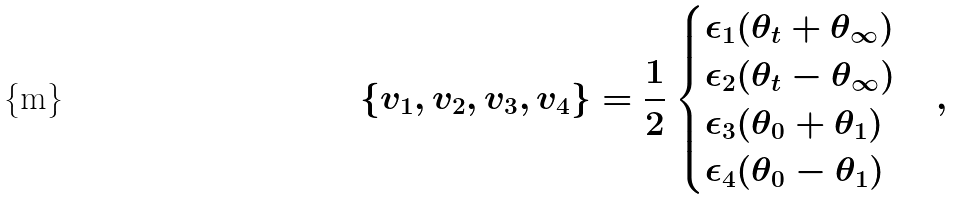Convert formula to latex. <formula><loc_0><loc_0><loc_500><loc_500>\{ v _ { 1 } , v _ { 2 } , v _ { 3 } , v _ { 4 } \} = \frac { 1 } { 2 } \begin{cases} \epsilon _ { 1 } ( \theta _ { t } + \theta _ { \infty } ) \\ \epsilon _ { 2 } ( \theta _ { t } - \theta _ { \infty } ) \\ \epsilon _ { 3 } ( \theta _ { 0 } + \theta _ { 1 } ) \\ \epsilon _ { 4 } ( \theta _ { 0 } - \theta _ { 1 } ) \\ \end{cases} ,</formula> 